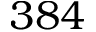<formula> <loc_0><loc_0><loc_500><loc_500>3 8 4</formula> 